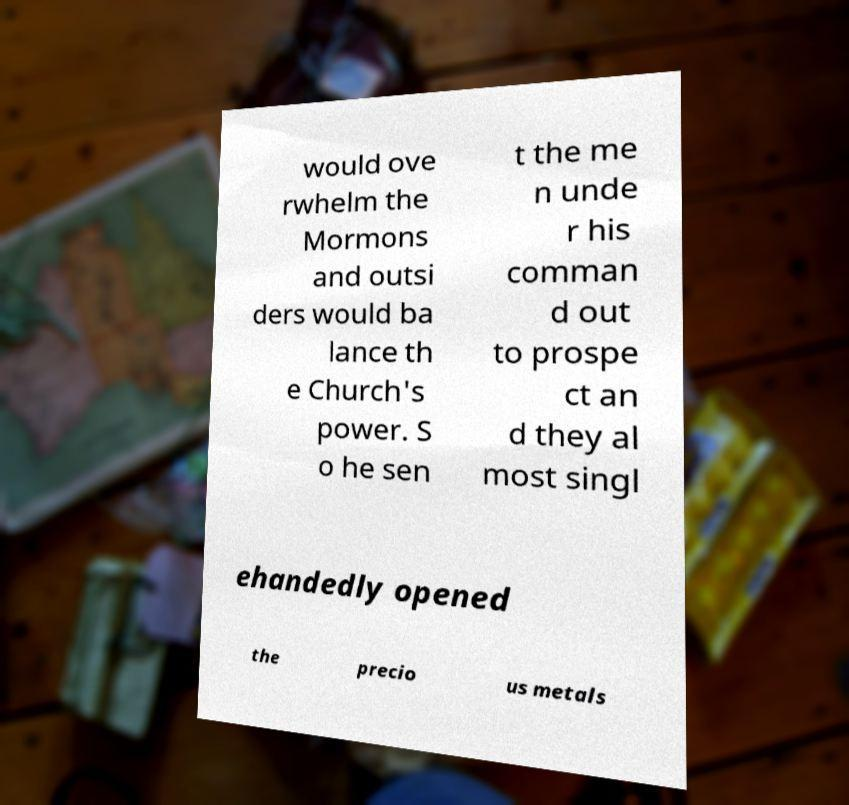Can you read and provide the text displayed in the image?This photo seems to have some interesting text. Can you extract and type it out for me? would ove rwhelm the Mormons and outsi ders would ba lance th e Church's power. S o he sen t the me n unde r his comman d out to prospe ct an d they al most singl ehandedly opened the precio us metals 